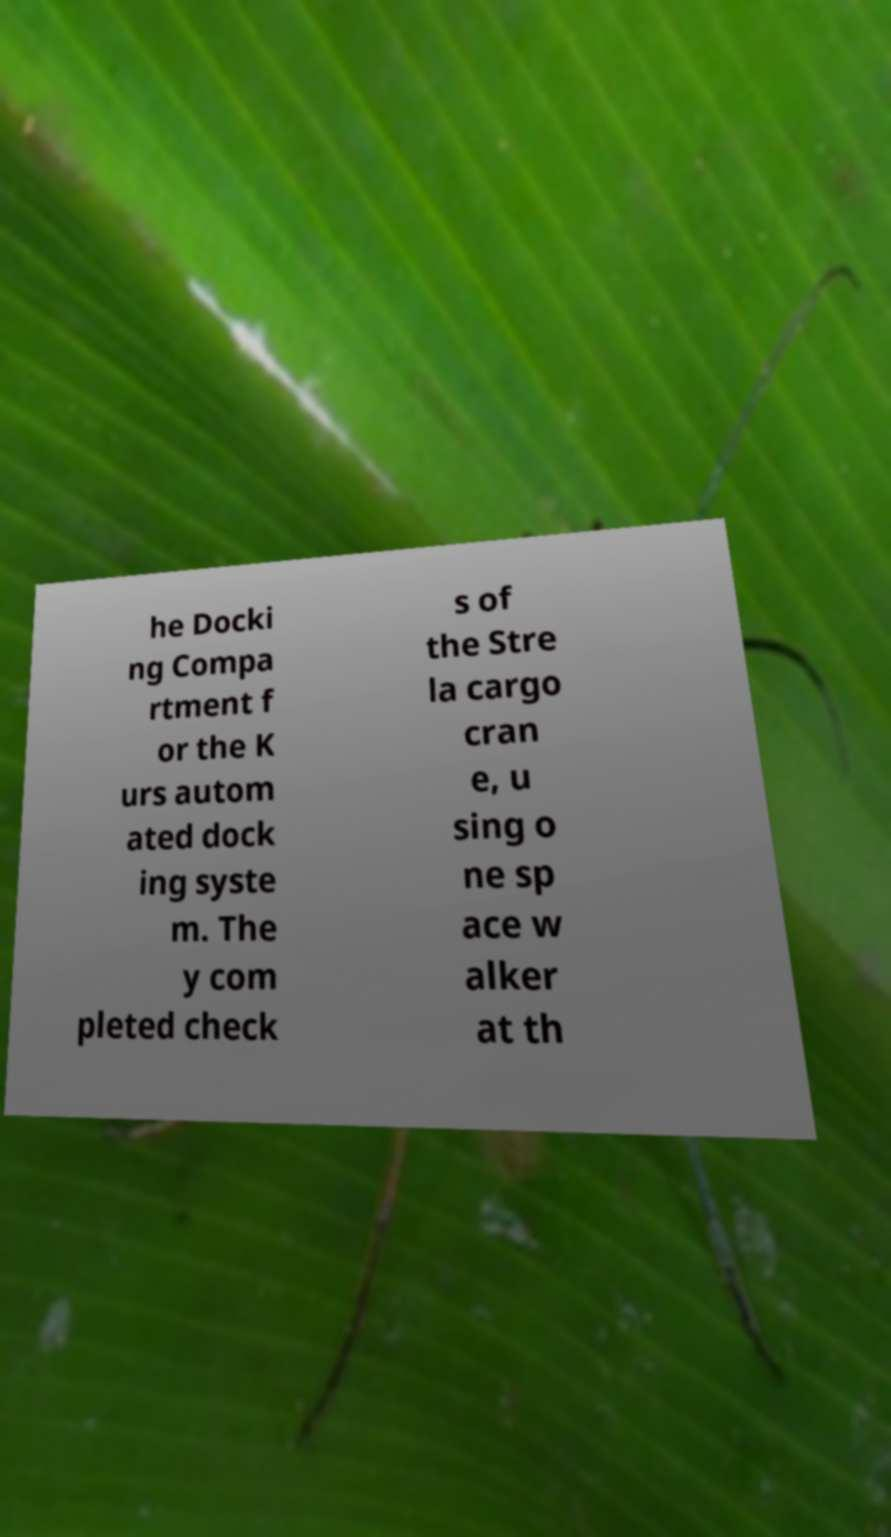Please read and relay the text visible in this image. What does it say? he Docki ng Compa rtment f or the K urs autom ated dock ing syste m. The y com pleted check s of the Stre la cargo cran e, u sing o ne sp ace w alker at th 